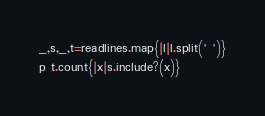<code> <loc_0><loc_0><loc_500><loc_500><_Ruby_>_,s,_,t=readlines.map{|l|l.split(' ')}
p t.count{|x|s.include?(x)}
</code> 